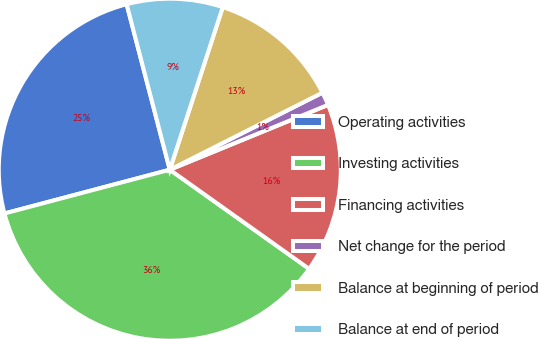Convert chart. <chart><loc_0><loc_0><loc_500><loc_500><pie_chart><fcel>Operating activities<fcel>Investing activities<fcel>Financing activities<fcel>Net change for the period<fcel>Balance at beginning of period<fcel>Balance at end of period<nl><fcel>25.06%<fcel>36.04%<fcel>16.03%<fcel>1.25%<fcel>12.55%<fcel>9.07%<nl></chart> 